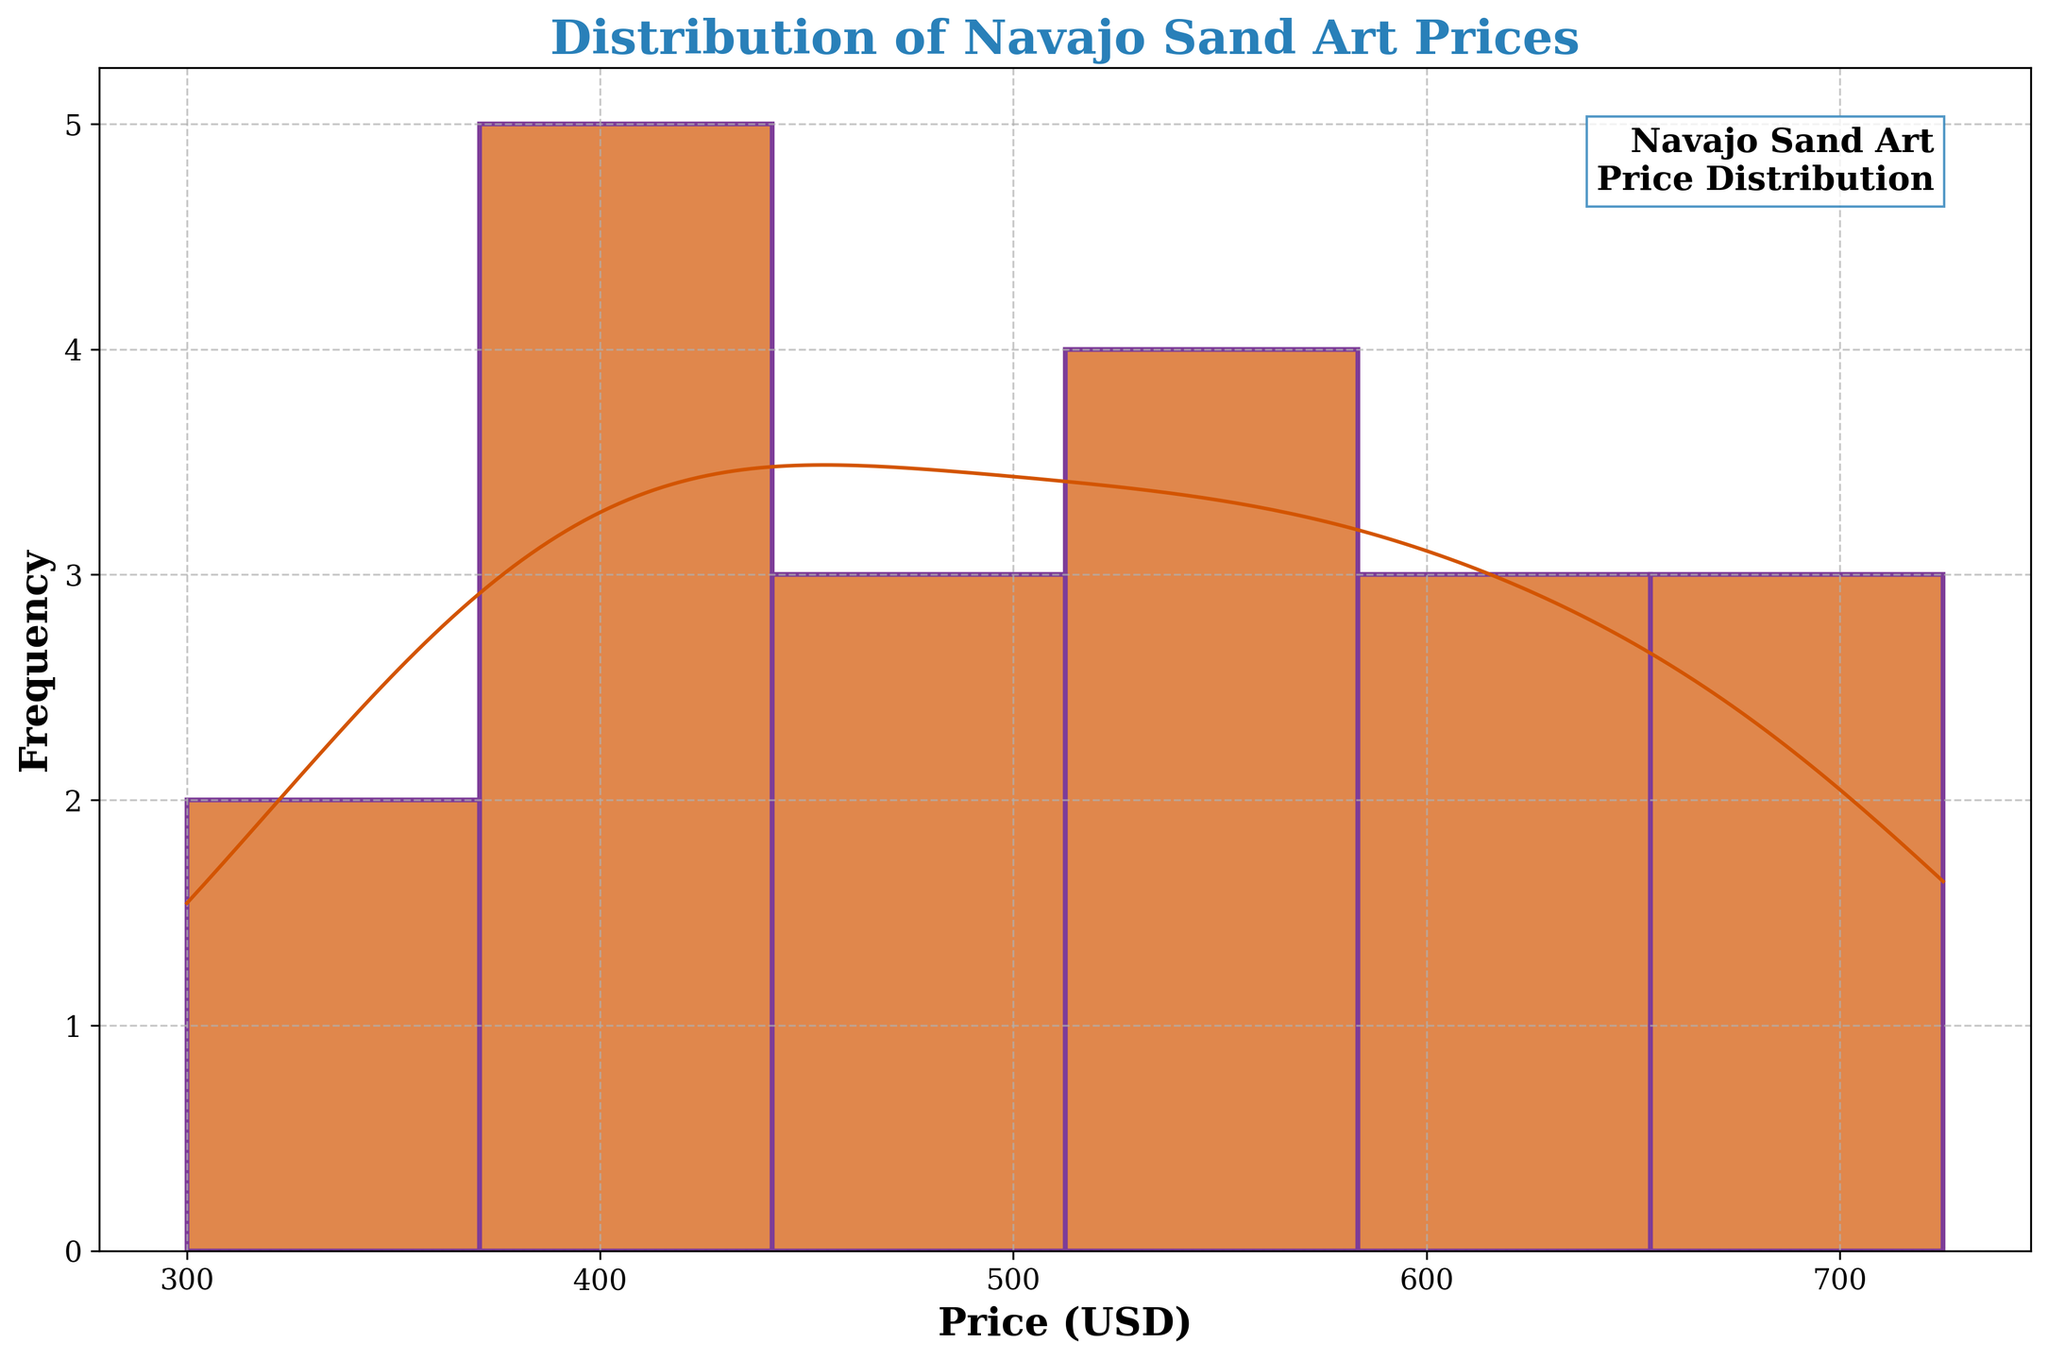What is the title of the figure? The title is found at the top of the figure. It provides a summary of the information visualized in the figure.
Answer: Distribution of Navajo Sand Art Prices How many main peaks can you identify in the KDE curve? By looking at the KDE (density) curve overlayed on the histogram, you can see the peaks representing where the data is most concentrated.
Answer: Two What is the price range with the highest frequency of sold Navajo sand art pieces? You need to examine the histogram bars and identify the interval with the highest bar, indicating the highest frequency of data points.
Answer: 400 - 500 USD What is the approximate median price of the sold sand art pieces? The median price can be estimated by finding the central value on the KDE curve. Since the data appears to be somewhat symmetrically distributed, it will be close to the mean of the highest concentration interval.
Answer: Around 500 USD Which gallery has the highest price for a piece of Navajo sand art and what is that price? Look at the data used to generate the plot; the maximum value represents the highest price. Identify the corresponding gallery from the data.
Answer: Toh-Atin Gallery, 725 USD Is there a price interval where no Navajo sand art pieces were sold? Check the histogram for any gaps where the frequency drops to zero.
Answer: 700 - 725 USD What do the colors of the histogram bars and the KDE curve represent? The colors help differentiate between the histogram bars and the KDE curve. The histogram bars are shown in one color, while the KDE curve is outlined with another.
Answer: Histogram bars are orange, KDE curve is purple, and the text annotations are in blue How does the grid style contribute to the readability of the figure? The grid is set with a dashed line style and slight transparency, which helps distinguish the data distribution without overwhelming the visual.
Answer: Enhances readability without distracting What is the price range where the second-highest density of prices occurs, according to the KDE curve? Examine the KDE curve for the second-highest peak, which indicates the second-most concentrated prices after the main peak.
Answer: 600 - 700 USD Does the KDE curve suggest a unimodal or multimodal distribution of prices? A unimodal distribution has one peak, while a multimodal distribution has multiple peaks. Count the peaks in the KDE curve.
Answer: Multimodal, with at least two peaks 